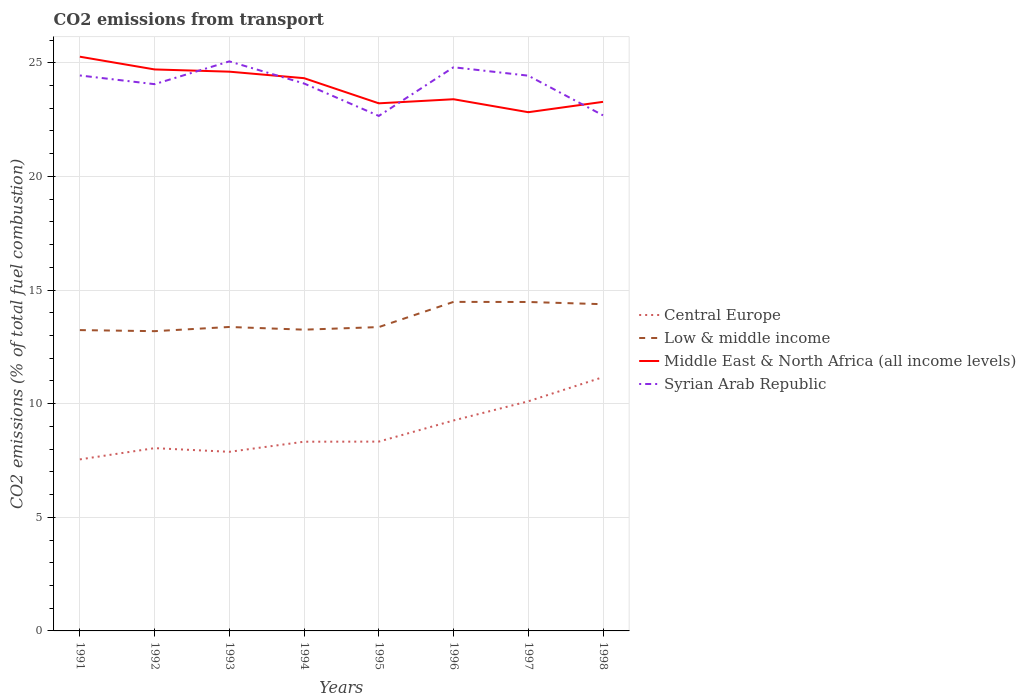How many different coloured lines are there?
Offer a very short reply. 4. Does the line corresponding to Low & middle income intersect with the line corresponding to Middle East & North Africa (all income levels)?
Make the answer very short. No. Across all years, what is the maximum total CO2 emitted in Syrian Arab Republic?
Give a very brief answer. 22.66. What is the total total CO2 emitted in Low & middle income in the graph?
Make the answer very short. -1.19. What is the difference between the highest and the second highest total CO2 emitted in Syrian Arab Republic?
Offer a terse response. 2.4. What is the difference between the highest and the lowest total CO2 emitted in Low & middle income?
Your answer should be very brief. 3. Is the total CO2 emitted in Syrian Arab Republic strictly greater than the total CO2 emitted in Central Europe over the years?
Provide a succinct answer. No. How many lines are there?
Provide a short and direct response. 4. What is the difference between two consecutive major ticks on the Y-axis?
Your answer should be very brief. 5. What is the title of the graph?
Offer a terse response. CO2 emissions from transport. Does "Central African Republic" appear as one of the legend labels in the graph?
Ensure brevity in your answer.  No. What is the label or title of the X-axis?
Make the answer very short. Years. What is the label or title of the Y-axis?
Give a very brief answer. CO2 emissions (% of total fuel combustion). What is the CO2 emissions (% of total fuel combustion) of Central Europe in 1991?
Your answer should be compact. 7.55. What is the CO2 emissions (% of total fuel combustion) in Low & middle income in 1991?
Your answer should be compact. 13.24. What is the CO2 emissions (% of total fuel combustion) of Middle East & North Africa (all income levels) in 1991?
Offer a very short reply. 25.26. What is the CO2 emissions (% of total fuel combustion) in Syrian Arab Republic in 1991?
Provide a succinct answer. 24.44. What is the CO2 emissions (% of total fuel combustion) of Central Europe in 1992?
Provide a succinct answer. 8.04. What is the CO2 emissions (% of total fuel combustion) of Low & middle income in 1992?
Keep it short and to the point. 13.19. What is the CO2 emissions (% of total fuel combustion) of Middle East & North Africa (all income levels) in 1992?
Offer a terse response. 24.7. What is the CO2 emissions (% of total fuel combustion) of Syrian Arab Republic in 1992?
Your answer should be compact. 24.06. What is the CO2 emissions (% of total fuel combustion) in Central Europe in 1993?
Ensure brevity in your answer.  7.88. What is the CO2 emissions (% of total fuel combustion) in Low & middle income in 1993?
Offer a terse response. 13.37. What is the CO2 emissions (% of total fuel combustion) of Middle East & North Africa (all income levels) in 1993?
Offer a very short reply. 24.61. What is the CO2 emissions (% of total fuel combustion) in Syrian Arab Republic in 1993?
Keep it short and to the point. 25.06. What is the CO2 emissions (% of total fuel combustion) of Central Europe in 1994?
Provide a succinct answer. 8.33. What is the CO2 emissions (% of total fuel combustion) in Low & middle income in 1994?
Give a very brief answer. 13.26. What is the CO2 emissions (% of total fuel combustion) of Middle East & North Africa (all income levels) in 1994?
Give a very brief answer. 24.32. What is the CO2 emissions (% of total fuel combustion) in Syrian Arab Republic in 1994?
Your answer should be very brief. 24.09. What is the CO2 emissions (% of total fuel combustion) in Central Europe in 1995?
Provide a short and direct response. 8.33. What is the CO2 emissions (% of total fuel combustion) of Low & middle income in 1995?
Offer a very short reply. 13.37. What is the CO2 emissions (% of total fuel combustion) of Middle East & North Africa (all income levels) in 1995?
Offer a very short reply. 23.21. What is the CO2 emissions (% of total fuel combustion) in Syrian Arab Republic in 1995?
Provide a succinct answer. 22.66. What is the CO2 emissions (% of total fuel combustion) in Central Europe in 1996?
Offer a very short reply. 9.26. What is the CO2 emissions (% of total fuel combustion) of Low & middle income in 1996?
Provide a short and direct response. 14.48. What is the CO2 emissions (% of total fuel combustion) in Middle East & North Africa (all income levels) in 1996?
Offer a terse response. 23.39. What is the CO2 emissions (% of total fuel combustion) of Syrian Arab Republic in 1996?
Provide a short and direct response. 24.8. What is the CO2 emissions (% of total fuel combustion) in Central Europe in 1997?
Keep it short and to the point. 10.1. What is the CO2 emissions (% of total fuel combustion) in Low & middle income in 1997?
Provide a succinct answer. 14.47. What is the CO2 emissions (% of total fuel combustion) of Middle East & North Africa (all income levels) in 1997?
Offer a very short reply. 22.82. What is the CO2 emissions (% of total fuel combustion) in Syrian Arab Republic in 1997?
Offer a very short reply. 24.43. What is the CO2 emissions (% of total fuel combustion) of Central Europe in 1998?
Offer a terse response. 11.17. What is the CO2 emissions (% of total fuel combustion) of Low & middle income in 1998?
Offer a very short reply. 14.38. What is the CO2 emissions (% of total fuel combustion) in Middle East & North Africa (all income levels) in 1998?
Keep it short and to the point. 23.28. What is the CO2 emissions (% of total fuel combustion) of Syrian Arab Republic in 1998?
Offer a very short reply. 22.68. Across all years, what is the maximum CO2 emissions (% of total fuel combustion) in Central Europe?
Ensure brevity in your answer.  11.17. Across all years, what is the maximum CO2 emissions (% of total fuel combustion) in Low & middle income?
Provide a short and direct response. 14.48. Across all years, what is the maximum CO2 emissions (% of total fuel combustion) of Middle East & North Africa (all income levels)?
Your answer should be very brief. 25.26. Across all years, what is the maximum CO2 emissions (% of total fuel combustion) of Syrian Arab Republic?
Keep it short and to the point. 25.06. Across all years, what is the minimum CO2 emissions (% of total fuel combustion) of Central Europe?
Offer a terse response. 7.55. Across all years, what is the minimum CO2 emissions (% of total fuel combustion) in Low & middle income?
Make the answer very short. 13.19. Across all years, what is the minimum CO2 emissions (% of total fuel combustion) of Middle East & North Africa (all income levels)?
Your answer should be very brief. 22.82. Across all years, what is the minimum CO2 emissions (% of total fuel combustion) in Syrian Arab Republic?
Provide a succinct answer. 22.66. What is the total CO2 emissions (% of total fuel combustion) of Central Europe in the graph?
Provide a short and direct response. 70.65. What is the total CO2 emissions (% of total fuel combustion) in Low & middle income in the graph?
Your response must be concise. 109.75. What is the total CO2 emissions (% of total fuel combustion) of Middle East & North Africa (all income levels) in the graph?
Your answer should be compact. 191.61. What is the total CO2 emissions (% of total fuel combustion) in Syrian Arab Republic in the graph?
Your answer should be compact. 192.22. What is the difference between the CO2 emissions (% of total fuel combustion) in Central Europe in 1991 and that in 1992?
Your response must be concise. -0.49. What is the difference between the CO2 emissions (% of total fuel combustion) of Low & middle income in 1991 and that in 1992?
Your answer should be very brief. 0.05. What is the difference between the CO2 emissions (% of total fuel combustion) in Middle East & North Africa (all income levels) in 1991 and that in 1992?
Offer a very short reply. 0.56. What is the difference between the CO2 emissions (% of total fuel combustion) of Syrian Arab Republic in 1991 and that in 1992?
Your answer should be very brief. 0.38. What is the difference between the CO2 emissions (% of total fuel combustion) in Central Europe in 1991 and that in 1993?
Ensure brevity in your answer.  -0.33. What is the difference between the CO2 emissions (% of total fuel combustion) of Low & middle income in 1991 and that in 1993?
Your response must be concise. -0.14. What is the difference between the CO2 emissions (% of total fuel combustion) in Middle East & North Africa (all income levels) in 1991 and that in 1993?
Ensure brevity in your answer.  0.66. What is the difference between the CO2 emissions (% of total fuel combustion) in Syrian Arab Republic in 1991 and that in 1993?
Your answer should be very brief. -0.62. What is the difference between the CO2 emissions (% of total fuel combustion) of Central Europe in 1991 and that in 1994?
Offer a terse response. -0.78. What is the difference between the CO2 emissions (% of total fuel combustion) of Low & middle income in 1991 and that in 1994?
Provide a succinct answer. -0.02. What is the difference between the CO2 emissions (% of total fuel combustion) in Middle East & North Africa (all income levels) in 1991 and that in 1994?
Offer a terse response. 0.94. What is the difference between the CO2 emissions (% of total fuel combustion) in Syrian Arab Republic in 1991 and that in 1994?
Make the answer very short. 0.35. What is the difference between the CO2 emissions (% of total fuel combustion) in Central Europe in 1991 and that in 1995?
Make the answer very short. -0.78. What is the difference between the CO2 emissions (% of total fuel combustion) of Low & middle income in 1991 and that in 1995?
Your answer should be compact. -0.13. What is the difference between the CO2 emissions (% of total fuel combustion) in Middle East & North Africa (all income levels) in 1991 and that in 1995?
Make the answer very short. 2.05. What is the difference between the CO2 emissions (% of total fuel combustion) of Syrian Arab Republic in 1991 and that in 1995?
Offer a terse response. 1.78. What is the difference between the CO2 emissions (% of total fuel combustion) of Central Europe in 1991 and that in 1996?
Provide a short and direct response. -1.71. What is the difference between the CO2 emissions (% of total fuel combustion) of Low & middle income in 1991 and that in 1996?
Your answer should be compact. -1.24. What is the difference between the CO2 emissions (% of total fuel combustion) of Middle East & North Africa (all income levels) in 1991 and that in 1996?
Give a very brief answer. 1.87. What is the difference between the CO2 emissions (% of total fuel combustion) in Syrian Arab Republic in 1991 and that in 1996?
Provide a short and direct response. -0.36. What is the difference between the CO2 emissions (% of total fuel combustion) of Central Europe in 1991 and that in 1997?
Provide a succinct answer. -2.56. What is the difference between the CO2 emissions (% of total fuel combustion) in Low & middle income in 1991 and that in 1997?
Provide a succinct answer. -1.24. What is the difference between the CO2 emissions (% of total fuel combustion) in Middle East & North Africa (all income levels) in 1991 and that in 1997?
Your answer should be compact. 2.44. What is the difference between the CO2 emissions (% of total fuel combustion) of Syrian Arab Republic in 1991 and that in 1997?
Give a very brief answer. 0.01. What is the difference between the CO2 emissions (% of total fuel combustion) in Central Europe in 1991 and that in 1998?
Offer a very short reply. -3.62. What is the difference between the CO2 emissions (% of total fuel combustion) of Low & middle income in 1991 and that in 1998?
Ensure brevity in your answer.  -1.14. What is the difference between the CO2 emissions (% of total fuel combustion) in Middle East & North Africa (all income levels) in 1991 and that in 1998?
Make the answer very short. 1.99. What is the difference between the CO2 emissions (% of total fuel combustion) of Syrian Arab Republic in 1991 and that in 1998?
Give a very brief answer. 1.75. What is the difference between the CO2 emissions (% of total fuel combustion) of Central Europe in 1992 and that in 1993?
Provide a succinct answer. 0.16. What is the difference between the CO2 emissions (% of total fuel combustion) of Low & middle income in 1992 and that in 1993?
Your response must be concise. -0.18. What is the difference between the CO2 emissions (% of total fuel combustion) of Middle East & North Africa (all income levels) in 1992 and that in 1993?
Provide a succinct answer. 0.1. What is the difference between the CO2 emissions (% of total fuel combustion) of Syrian Arab Republic in 1992 and that in 1993?
Your answer should be compact. -1. What is the difference between the CO2 emissions (% of total fuel combustion) of Central Europe in 1992 and that in 1994?
Offer a very short reply. -0.28. What is the difference between the CO2 emissions (% of total fuel combustion) in Low & middle income in 1992 and that in 1994?
Provide a succinct answer. -0.07. What is the difference between the CO2 emissions (% of total fuel combustion) of Middle East & North Africa (all income levels) in 1992 and that in 1994?
Provide a succinct answer. 0.38. What is the difference between the CO2 emissions (% of total fuel combustion) of Syrian Arab Republic in 1992 and that in 1994?
Your response must be concise. -0.03. What is the difference between the CO2 emissions (% of total fuel combustion) in Central Europe in 1992 and that in 1995?
Your response must be concise. -0.29. What is the difference between the CO2 emissions (% of total fuel combustion) of Low & middle income in 1992 and that in 1995?
Your answer should be very brief. -0.18. What is the difference between the CO2 emissions (% of total fuel combustion) in Middle East & North Africa (all income levels) in 1992 and that in 1995?
Give a very brief answer. 1.49. What is the difference between the CO2 emissions (% of total fuel combustion) in Syrian Arab Republic in 1992 and that in 1995?
Your response must be concise. 1.4. What is the difference between the CO2 emissions (% of total fuel combustion) in Central Europe in 1992 and that in 1996?
Ensure brevity in your answer.  -1.22. What is the difference between the CO2 emissions (% of total fuel combustion) in Low & middle income in 1992 and that in 1996?
Your answer should be compact. -1.29. What is the difference between the CO2 emissions (% of total fuel combustion) in Middle East & North Africa (all income levels) in 1992 and that in 1996?
Your answer should be very brief. 1.31. What is the difference between the CO2 emissions (% of total fuel combustion) of Syrian Arab Republic in 1992 and that in 1996?
Your response must be concise. -0.74. What is the difference between the CO2 emissions (% of total fuel combustion) of Central Europe in 1992 and that in 1997?
Your answer should be compact. -2.06. What is the difference between the CO2 emissions (% of total fuel combustion) in Low & middle income in 1992 and that in 1997?
Make the answer very short. -1.28. What is the difference between the CO2 emissions (% of total fuel combustion) of Middle East & North Africa (all income levels) in 1992 and that in 1997?
Your answer should be compact. 1.88. What is the difference between the CO2 emissions (% of total fuel combustion) of Syrian Arab Republic in 1992 and that in 1997?
Your answer should be compact. -0.37. What is the difference between the CO2 emissions (% of total fuel combustion) in Central Europe in 1992 and that in 1998?
Provide a succinct answer. -3.12. What is the difference between the CO2 emissions (% of total fuel combustion) of Low & middle income in 1992 and that in 1998?
Keep it short and to the point. -1.19. What is the difference between the CO2 emissions (% of total fuel combustion) of Middle East & North Africa (all income levels) in 1992 and that in 1998?
Provide a short and direct response. 1.43. What is the difference between the CO2 emissions (% of total fuel combustion) in Syrian Arab Republic in 1992 and that in 1998?
Your answer should be compact. 1.37. What is the difference between the CO2 emissions (% of total fuel combustion) of Central Europe in 1993 and that in 1994?
Offer a very short reply. -0.44. What is the difference between the CO2 emissions (% of total fuel combustion) of Low & middle income in 1993 and that in 1994?
Offer a very short reply. 0.12. What is the difference between the CO2 emissions (% of total fuel combustion) of Middle East & North Africa (all income levels) in 1993 and that in 1994?
Your answer should be very brief. 0.29. What is the difference between the CO2 emissions (% of total fuel combustion) of Syrian Arab Republic in 1993 and that in 1994?
Your answer should be very brief. 0.97. What is the difference between the CO2 emissions (% of total fuel combustion) in Central Europe in 1993 and that in 1995?
Ensure brevity in your answer.  -0.45. What is the difference between the CO2 emissions (% of total fuel combustion) of Low & middle income in 1993 and that in 1995?
Your answer should be compact. 0.01. What is the difference between the CO2 emissions (% of total fuel combustion) in Middle East & North Africa (all income levels) in 1993 and that in 1995?
Provide a succinct answer. 1.39. What is the difference between the CO2 emissions (% of total fuel combustion) in Syrian Arab Republic in 1993 and that in 1995?
Offer a very short reply. 2.4. What is the difference between the CO2 emissions (% of total fuel combustion) of Central Europe in 1993 and that in 1996?
Offer a very short reply. -1.38. What is the difference between the CO2 emissions (% of total fuel combustion) of Low & middle income in 1993 and that in 1996?
Provide a short and direct response. -1.1. What is the difference between the CO2 emissions (% of total fuel combustion) in Middle East & North Africa (all income levels) in 1993 and that in 1996?
Offer a very short reply. 1.21. What is the difference between the CO2 emissions (% of total fuel combustion) in Syrian Arab Republic in 1993 and that in 1996?
Give a very brief answer. 0.26. What is the difference between the CO2 emissions (% of total fuel combustion) in Central Europe in 1993 and that in 1997?
Ensure brevity in your answer.  -2.22. What is the difference between the CO2 emissions (% of total fuel combustion) of Low & middle income in 1993 and that in 1997?
Provide a succinct answer. -1.1. What is the difference between the CO2 emissions (% of total fuel combustion) of Middle East & North Africa (all income levels) in 1993 and that in 1997?
Ensure brevity in your answer.  1.78. What is the difference between the CO2 emissions (% of total fuel combustion) of Syrian Arab Republic in 1993 and that in 1997?
Ensure brevity in your answer.  0.63. What is the difference between the CO2 emissions (% of total fuel combustion) of Central Europe in 1993 and that in 1998?
Provide a succinct answer. -3.29. What is the difference between the CO2 emissions (% of total fuel combustion) in Low & middle income in 1993 and that in 1998?
Your response must be concise. -1. What is the difference between the CO2 emissions (% of total fuel combustion) in Middle East & North Africa (all income levels) in 1993 and that in 1998?
Your response must be concise. 1.33. What is the difference between the CO2 emissions (% of total fuel combustion) of Syrian Arab Republic in 1993 and that in 1998?
Your answer should be compact. 2.37. What is the difference between the CO2 emissions (% of total fuel combustion) of Central Europe in 1994 and that in 1995?
Your response must be concise. -0. What is the difference between the CO2 emissions (% of total fuel combustion) of Low & middle income in 1994 and that in 1995?
Provide a short and direct response. -0.11. What is the difference between the CO2 emissions (% of total fuel combustion) in Middle East & North Africa (all income levels) in 1994 and that in 1995?
Make the answer very short. 1.11. What is the difference between the CO2 emissions (% of total fuel combustion) in Syrian Arab Republic in 1994 and that in 1995?
Keep it short and to the point. 1.43. What is the difference between the CO2 emissions (% of total fuel combustion) in Central Europe in 1994 and that in 1996?
Make the answer very short. -0.93. What is the difference between the CO2 emissions (% of total fuel combustion) of Low & middle income in 1994 and that in 1996?
Offer a terse response. -1.22. What is the difference between the CO2 emissions (% of total fuel combustion) of Middle East & North Africa (all income levels) in 1994 and that in 1996?
Make the answer very short. 0.93. What is the difference between the CO2 emissions (% of total fuel combustion) of Syrian Arab Republic in 1994 and that in 1996?
Make the answer very short. -0.71. What is the difference between the CO2 emissions (% of total fuel combustion) of Central Europe in 1994 and that in 1997?
Your response must be concise. -1.78. What is the difference between the CO2 emissions (% of total fuel combustion) of Low & middle income in 1994 and that in 1997?
Offer a terse response. -1.22. What is the difference between the CO2 emissions (% of total fuel combustion) of Middle East & North Africa (all income levels) in 1994 and that in 1997?
Your response must be concise. 1.5. What is the difference between the CO2 emissions (% of total fuel combustion) in Syrian Arab Republic in 1994 and that in 1997?
Ensure brevity in your answer.  -0.34. What is the difference between the CO2 emissions (% of total fuel combustion) in Central Europe in 1994 and that in 1998?
Provide a short and direct response. -2.84. What is the difference between the CO2 emissions (% of total fuel combustion) of Low & middle income in 1994 and that in 1998?
Give a very brief answer. -1.12. What is the difference between the CO2 emissions (% of total fuel combustion) in Middle East & North Africa (all income levels) in 1994 and that in 1998?
Offer a very short reply. 1.04. What is the difference between the CO2 emissions (% of total fuel combustion) in Syrian Arab Republic in 1994 and that in 1998?
Keep it short and to the point. 1.4. What is the difference between the CO2 emissions (% of total fuel combustion) in Central Europe in 1995 and that in 1996?
Provide a succinct answer. -0.93. What is the difference between the CO2 emissions (% of total fuel combustion) in Low & middle income in 1995 and that in 1996?
Provide a succinct answer. -1.11. What is the difference between the CO2 emissions (% of total fuel combustion) in Middle East & North Africa (all income levels) in 1995 and that in 1996?
Your response must be concise. -0.18. What is the difference between the CO2 emissions (% of total fuel combustion) in Syrian Arab Republic in 1995 and that in 1996?
Your answer should be compact. -2.14. What is the difference between the CO2 emissions (% of total fuel combustion) in Central Europe in 1995 and that in 1997?
Offer a terse response. -1.77. What is the difference between the CO2 emissions (% of total fuel combustion) of Low & middle income in 1995 and that in 1997?
Give a very brief answer. -1.1. What is the difference between the CO2 emissions (% of total fuel combustion) in Middle East & North Africa (all income levels) in 1995 and that in 1997?
Provide a short and direct response. 0.39. What is the difference between the CO2 emissions (% of total fuel combustion) in Syrian Arab Republic in 1995 and that in 1997?
Keep it short and to the point. -1.77. What is the difference between the CO2 emissions (% of total fuel combustion) in Central Europe in 1995 and that in 1998?
Your answer should be very brief. -2.84. What is the difference between the CO2 emissions (% of total fuel combustion) in Low & middle income in 1995 and that in 1998?
Ensure brevity in your answer.  -1.01. What is the difference between the CO2 emissions (% of total fuel combustion) in Middle East & North Africa (all income levels) in 1995 and that in 1998?
Offer a very short reply. -0.06. What is the difference between the CO2 emissions (% of total fuel combustion) in Syrian Arab Republic in 1995 and that in 1998?
Offer a very short reply. -0.03. What is the difference between the CO2 emissions (% of total fuel combustion) of Central Europe in 1996 and that in 1997?
Offer a very short reply. -0.84. What is the difference between the CO2 emissions (% of total fuel combustion) in Low & middle income in 1996 and that in 1997?
Give a very brief answer. 0. What is the difference between the CO2 emissions (% of total fuel combustion) in Middle East & North Africa (all income levels) in 1996 and that in 1997?
Provide a short and direct response. 0.57. What is the difference between the CO2 emissions (% of total fuel combustion) of Syrian Arab Republic in 1996 and that in 1997?
Offer a very short reply. 0.37. What is the difference between the CO2 emissions (% of total fuel combustion) of Central Europe in 1996 and that in 1998?
Your answer should be compact. -1.91. What is the difference between the CO2 emissions (% of total fuel combustion) of Low & middle income in 1996 and that in 1998?
Your response must be concise. 0.1. What is the difference between the CO2 emissions (% of total fuel combustion) of Middle East & North Africa (all income levels) in 1996 and that in 1998?
Give a very brief answer. 0.12. What is the difference between the CO2 emissions (% of total fuel combustion) in Syrian Arab Republic in 1996 and that in 1998?
Offer a terse response. 2.12. What is the difference between the CO2 emissions (% of total fuel combustion) in Central Europe in 1997 and that in 1998?
Provide a succinct answer. -1.06. What is the difference between the CO2 emissions (% of total fuel combustion) of Low & middle income in 1997 and that in 1998?
Make the answer very short. 0.1. What is the difference between the CO2 emissions (% of total fuel combustion) of Middle East & North Africa (all income levels) in 1997 and that in 1998?
Your response must be concise. -0.46. What is the difference between the CO2 emissions (% of total fuel combustion) of Syrian Arab Republic in 1997 and that in 1998?
Make the answer very short. 1.75. What is the difference between the CO2 emissions (% of total fuel combustion) of Central Europe in 1991 and the CO2 emissions (% of total fuel combustion) of Low & middle income in 1992?
Offer a terse response. -5.64. What is the difference between the CO2 emissions (% of total fuel combustion) in Central Europe in 1991 and the CO2 emissions (% of total fuel combustion) in Middle East & North Africa (all income levels) in 1992?
Provide a short and direct response. -17.16. What is the difference between the CO2 emissions (% of total fuel combustion) of Central Europe in 1991 and the CO2 emissions (% of total fuel combustion) of Syrian Arab Republic in 1992?
Provide a short and direct response. -16.51. What is the difference between the CO2 emissions (% of total fuel combustion) of Low & middle income in 1991 and the CO2 emissions (% of total fuel combustion) of Middle East & North Africa (all income levels) in 1992?
Provide a succinct answer. -11.47. What is the difference between the CO2 emissions (% of total fuel combustion) of Low & middle income in 1991 and the CO2 emissions (% of total fuel combustion) of Syrian Arab Republic in 1992?
Provide a short and direct response. -10.82. What is the difference between the CO2 emissions (% of total fuel combustion) of Middle East & North Africa (all income levels) in 1991 and the CO2 emissions (% of total fuel combustion) of Syrian Arab Republic in 1992?
Ensure brevity in your answer.  1.21. What is the difference between the CO2 emissions (% of total fuel combustion) of Central Europe in 1991 and the CO2 emissions (% of total fuel combustion) of Low & middle income in 1993?
Make the answer very short. -5.83. What is the difference between the CO2 emissions (% of total fuel combustion) of Central Europe in 1991 and the CO2 emissions (% of total fuel combustion) of Middle East & North Africa (all income levels) in 1993?
Give a very brief answer. -17.06. What is the difference between the CO2 emissions (% of total fuel combustion) of Central Europe in 1991 and the CO2 emissions (% of total fuel combustion) of Syrian Arab Republic in 1993?
Keep it short and to the point. -17.51. What is the difference between the CO2 emissions (% of total fuel combustion) in Low & middle income in 1991 and the CO2 emissions (% of total fuel combustion) in Middle East & North Africa (all income levels) in 1993?
Offer a very short reply. -11.37. What is the difference between the CO2 emissions (% of total fuel combustion) in Low & middle income in 1991 and the CO2 emissions (% of total fuel combustion) in Syrian Arab Republic in 1993?
Make the answer very short. -11.82. What is the difference between the CO2 emissions (% of total fuel combustion) in Middle East & North Africa (all income levels) in 1991 and the CO2 emissions (% of total fuel combustion) in Syrian Arab Republic in 1993?
Offer a very short reply. 0.21. What is the difference between the CO2 emissions (% of total fuel combustion) of Central Europe in 1991 and the CO2 emissions (% of total fuel combustion) of Low & middle income in 1994?
Your response must be concise. -5.71. What is the difference between the CO2 emissions (% of total fuel combustion) of Central Europe in 1991 and the CO2 emissions (% of total fuel combustion) of Middle East & North Africa (all income levels) in 1994?
Offer a terse response. -16.77. What is the difference between the CO2 emissions (% of total fuel combustion) in Central Europe in 1991 and the CO2 emissions (% of total fuel combustion) in Syrian Arab Republic in 1994?
Offer a terse response. -16.54. What is the difference between the CO2 emissions (% of total fuel combustion) in Low & middle income in 1991 and the CO2 emissions (% of total fuel combustion) in Middle East & North Africa (all income levels) in 1994?
Ensure brevity in your answer.  -11.08. What is the difference between the CO2 emissions (% of total fuel combustion) of Low & middle income in 1991 and the CO2 emissions (% of total fuel combustion) of Syrian Arab Republic in 1994?
Offer a very short reply. -10.85. What is the difference between the CO2 emissions (% of total fuel combustion) of Middle East & North Africa (all income levels) in 1991 and the CO2 emissions (% of total fuel combustion) of Syrian Arab Republic in 1994?
Give a very brief answer. 1.18. What is the difference between the CO2 emissions (% of total fuel combustion) of Central Europe in 1991 and the CO2 emissions (% of total fuel combustion) of Low & middle income in 1995?
Ensure brevity in your answer.  -5.82. What is the difference between the CO2 emissions (% of total fuel combustion) of Central Europe in 1991 and the CO2 emissions (% of total fuel combustion) of Middle East & North Africa (all income levels) in 1995?
Provide a succinct answer. -15.67. What is the difference between the CO2 emissions (% of total fuel combustion) in Central Europe in 1991 and the CO2 emissions (% of total fuel combustion) in Syrian Arab Republic in 1995?
Ensure brevity in your answer.  -15.11. What is the difference between the CO2 emissions (% of total fuel combustion) in Low & middle income in 1991 and the CO2 emissions (% of total fuel combustion) in Middle East & North Africa (all income levels) in 1995?
Offer a terse response. -9.98. What is the difference between the CO2 emissions (% of total fuel combustion) in Low & middle income in 1991 and the CO2 emissions (% of total fuel combustion) in Syrian Arab Republic in 1995?
Make the answer very short. -9.42. What is the difference between the CO2 emissions (% of total fuel combustion) of Middle East & North Africa (all income levels) in 1991 and the CO2 emissions (% of total fuel combustion) of Syrian Arab Republic in 1995?
Offer a terse response. 2.61. What is the difference between the CO2 emissions (% of total fuel combustion) in Central Europe in 1991 and the CO2 emissions (% of total fuel combustion) in Low & middle income in 1996?
Your response must be concise. -6.93. What is the difference between the CO2 emissions (% of total fuel combustion) in Central Europe in 1991 and the CO2 emissions (% of total fuel combustion) in Middle East & North Africa (all income levels) in 1996?
Your answer should be compact. -15.85. What is the difference between the CO2 emissions (% of total fuel combustion) in Central Europe in 1991 and the CO2 emissions (% of total fuel combustion) in Syrian Arab Republic in 1996?
Keep it short and to the point. -17.25. What is the difference between the CO2 emissions (% of total fuel combustion) of Low & middle income in 1991 and the CO2 emissions (% of total fuel combustion) of Middle East & North Africa (all income levels) in 1996?
Make the answer very short. -10.16. What is the difference between the CO2 emissions (% of total fuel combustion) in Low & middle income in 1991 and the CO2 emissions (% of total fuel combustion) in Syrian Arab Republic in 1996?
Ensure brevity in your answer.  -11.56. What is the difference between the CO2 emissions (% of total fuel combustion) in Middle East & North Africa (all income levels) in 1991 and the CO2 emissions (% of total fuel combustion) in Syrian Arab Republic in 1996?
Provide a short and direct response. 0.46. What is the difference between the CO2 emissions (% of total fuel combustion) of Central Europe in 1991 and the CO2 emissions (% of total fuel combustion) of Low & middle income in 1997?
Offer a terse response. -6.93. What is the difference between the CO2 emissions (% of total fuel combustion) of Central Europe in 1991 and the CO2 emissions (% of total fuel combustion) of Middle East & North Africa (all income levels) in 1997?
Give a very brief answer. -15.28. What is the difference between the CO2 emissions (% of total fuel combustion) in Central Europe in 1991 and the CO2 emissions (% of total fuel combustion) in Syrian Arab Republic in 1997?
Provide a succinct answer. -16.88. What is the difference between the CO2 emissions (% of total fuel combustion) of Low & middle income in 1991 and the CO2 emissions (% of total fuel combustion) of Middle East & North Africa (all income levels) in 1997?
Provide a short and direct response. -9.59. What is the difference between the CO2 emissions (% of total fuel combustion) of Low & middle income in 1991 and the CO2 emissions (% of total fuel combustion) of Syrian Arab Republic in 1997?
Your response must be concise. -11.2. What is the difference between the CO2 emissions (% of total fuel combustion) of Middle East & North Africa (all income levels) in 1991 and the CO2 emissions (% of total fuel combustion) of Syrian Arab Republic in 1997?
Your response must be concise. 0.83. What is the difference between the CO2 emissions (% of total fuel combustion) of Central Europe in 1991 and the CO2 emissions (% of total fuel combustion) of Low & middle income in 1998?
Keep it short and to the point. -6.83. What is the difference between the CO2 emissions (% of total fuel combustion) of Central Europe in 1991 and the CO2 emissions (% of total fuel combustion) of Middle East & North Africa (all income levels) in 1998?
Make the answer very short. -15.73. What is the difference between the CO2 emissions (% of total fuel combustion) of Central Europe in 1991 and the CO2 emissions (% of total fuel combustion) of Syrian Arab Republic in 1998?
Give a very brief answer. -15.14. What is the difference between the CO2 emissions (% of total fuel combustion) in Low & middle income in 1991 and the CO2 emissions (% of total fuel combustion) in Middle East & North Africa (all income levels) in 1998?
Provide a short and direct response. -10.04. What is the difference between the CO2 emissions (% of total fuel combustion) of Low & middle income in 1991 and the CO2 emissions (% of total fuel combustion) of Syrian Arab Republic in 1998?
Make the answer very short. -9.45. What is the difference between the CO2 emissions (% of total fuel combustion) in Middle East & North Africa (all income levels) in 1991 and the CO2 emissions (% of total fuel combustion) in Syrian Arab Republic in 1998?
Make the answer very short. 2.58. What is the difference between the CO2 emissions (% of total fuel combustion) in Central Europe in 1992 and the CO2 emissions (% of total fuel combustion) in Low & middle income in 1993?
Your response must be concise. -5.33. What is the difference between the CO2 emissions (% of total fuel combustion) in Central Europe in 1992 and the CO2 emissions (% of total fuel combustion) in Middle East & North Africa (all income levels) in 1993?
Your response must be concise. -16.57. What is the difference between the CO2 emissions (% of total fuel combustion) in Central Europe in 1992 and the CO2 emissions (% of total fuel combustion) in Syrian Arab Republic in 1993?
Provide a short and direct response. -17.02. What is the difference between the CO2 emissions (% of total fuel combustion) in Low & middle income in 1992 and the CO2 emissions (% of total fuel combustion) in Middle East & North Africa (all income levels) in 1993?
Provide a succinct answer. -11.42. What is the difference between the CO2 emissions (% of total fuel combustion) in Low & middle income in 1992 and the CO2 emissions (% of total fuel combustion) in Syrian Arab Republic in 1993?
Your answer should be very brief. -11.87. What is the difference between the CO2 emissions (% of total fuel combustion) of Middle East & North Africa (all income levels) in 1992 and the CO2 emissions (% of total fuel combustion) of Syrian Arab Republic in 1993?
Make the answer very short. -0.35. What is the difference between the CO2 emissions (% of total fuel combustion) in Central Europe in 1992 and the CO2 emissions (% of total fuel combustion) in Low & middle income in 1994?
Your response must be concise. -5.21. What is the difference between the CO2 emissions (% of total fuel combustion) in Central Europe in 1992 and the CO2 emissions (% of total fuel combustion) in Middle East & North Africa (all income levels) in 1994?
Your answer should be compact. -16.28. What is the difference between the CO2 emissions (% of total fuel combustion) of Central Europe in 1992 and the CO2 emissions (% of total fuel combustion) of Syrian Arab Republic in 1994?
Make the answer very short. -16.04. What is the difference between the CO2 emissions (% of total fuel combustion) in Low & middle income in 1992 and the CO2 emissions (% of total fuel combustion) in Middle East & North Africa (all income levels) in 1994?
Provide a succinct answer. -11.13. What is the difference between the CO2 emissions (% of total fuel combustion) in Low & middle income in 1992 and the CO2 emissions (% of total fuel combustion) in Syrian Arab Republic in 1994?
Offer a very short reply. -10.9. What is the difference between the CO2 emissions (% of total fuel combustion) in Middle East & North Africa (all income levels) in 1992 and the CO2 emissions (% of total fuel combustion) in Syrian Arab Republic in 1994?
Give a very brief answer. 0.62. What is the difference between the CO2 emissions (% of total fuel combustion) in Central Europe in 1992 and the CO2 emissions (% of total fuel combustion) in Low & middle income in 1995?
Offer a terse response. -5.33. What is the difference between the CO2 emissions (% of total fuel combustion) in Central Europe in 1992 and the CO2 emissions (% of total fuel combustion) in Middle East & North Africa (all income levels) in 1995?
Ensure brevity in your answer.  -15.17. What is the difference between the CO2 emissions (% of total fuel combustion) of Central Europe in 1992 and the CO2 emissions (% of total fuel combustion) of Syrian Arab Republic in 1995?
Offer a terse response. -14.62. What is the difference between the CO2 emissions (% of total fuel combustion) in Low & middle income in 1992 and the CO2 emissions (% of total fuel combustion) in Middle East & North Africa (all income levels) in 1995?
Your answer should be compact. -10.03. What is the difference between the CO2 emissions (% of total fuel combustion) in Low & middle income in 1992 and the CO2 emissions (% of total fuel combustion) in Syrian Arab Republic in 1995?
Provide a succinct answer. -9.47. What is the difference between the CO2 emissions (% of total fuel combustion) of Middle East & North Africa (all income levels) in 1992 and the CO2 emissions (% of total fuel combustion) of Syrian Arab Republic in 1995?
Provide a succinct answer. 2.05. What is the difference between the CO2 emissions (% of total fuel combustion) in Central Europe in 1992 and the CO2 emissions (% of total fuel combustion) in Low & middle income in 1996?
Your answer should be compact. -6.44. What is the difference between the CO2 emissions (% of total fuel combustion) in Central Europe in 1992 and the CO2 emissions (% of total fuel combustion) in Middle East & North Africa (all income levels) in 1996?
Give a very brief answer. -15.35. What is the difference between the CO2 emissions (% of total fuel combustion) of Central Europe in 1992 and the CO2 emissions (% of total fuel combustion) of Syrian Arab Republic in 1996?
Provide a short and direct response. -16.76. What is the difference between the CO2 emissions (% of total fuel combustion) in Low & middle income in 1992 and the CO2 emissions (% of total fuel combustion) in Middle East & North Africa (all income levels) in 1996?
Keep it short and to the point. -10.21. What is the difference between the CO2 emissions (% of total fuel combustion) in Low & middle income in 1992 and the CO2 emissions (% of total fuel combustion) in Syrian Arab Republic in 1996?
Your answer should be very brief. -11.61. What is the difference between the CO2 emissions (% of total fuel combustion) in Middle East & North Africa (all income levels) in 1992 and the CO2 emissions (% of total fuel combustion) in Syrian Arab Republic in 1996?
Make the answer very short. -0.1. What is the difference between the CO2 emissions (% of total fuel combustion) of Central Europe in 1992 and the CO2 emissions (% of total fuel combustion) of Low & middle income in 1997?
Keep it short and to the point. -6.43. What is the difference between the CO2 emissions (% of total fuel combustion) of Central Europe in 1992 and the CO2 emissions (% of total fuel combustion) of Middle East & North Africa (all income levels) in 1997?
Your response must be concise. -14.78. What is the difference between the CO2 emissions (% of total fuel combustion) of Central Europe in 1992 and the CO2 emissions (% of total fuel combustion) of Syrian Arab Republic in 1997?
Your answer should be very brief. -16.39. What is the difference between the CO2 emissions (% of total fuel combustion) in Low & middle income in 1992 and the CO2 emissions (% of total fuel combustion) in Middle East & North Africa (all income levels) in 1997?
Offer a very short reply. -9.63. What is the difference between the CO2 emissions (% of total fuel combustion) of Low & middle income in 1992 and the CO2 emissions (% of total fuel combustion) of Syrian Arab Republic in 1997?
Provide a short and direct response. -11.24. What is the difference between the CO2 emissions (% of total fuel combustion) of Middle East & North Africa (all income levels) in 1992 and the CO2 emissions (% of total fuel combustion) of Syrian Arab Republic in 1997?
Offer a terse response. 0.27. What is the difference between the CO2 emissions (% of total fuel combustion) in Central Europe in 1992 and the CO2 emissions (% of total fuel combustion) in Low & middle income in 1998?
Offer a very short reply. -6.33. What is the difference between the CO2 emissions (% of total fuel combustion) in Central Europe in 1992 and the CO2 emissions (% of total fuel combustion) in Middle East & North Africa (all income levels) in 1998?
Your answer should be very brief. -15.24. What is the difference between the CO2 emissions (% of total fuel combustion) of Central Europe in 1992 and the CO2 emissions (% of total fuel combustion) of Syrian Arab Republic in 1998?
Ensure brevity in your answer.  -14.64. What is the difference between the CO2 emissions (% of total fuel combustion) in Low & middle income in 1992 and the CO2 emissions (% of total fuel combustion) in Middle East & North Africa (all income levels) in 1998?
Make the answer very short. -10.09. What is the difference between the CO2 emissions (% of total fuel combustion) of Low & middle income in 1992 and the CO2 emissions (% of total fuel combustion) of Syrian Arab Republic in 1998?
Your response must be concise. -9.5. What is the difference between the CO2 emissions (% of total fuel combustion) in Middle East & North Africa (all income levels) in 1992 and the CO2 emissions (% of total fuel combustion) in Syrian Arab Republic in 1998?
Provide a short and direct response. 2.02. What is the difference between the CO2 emissions (% of total fuel combustion) in Central Europe in 1993 and the CO2 emissions (% of total fuel combustion) in Low & middle income in 1994?
Your answer should be compact. -5.37. What is the difference between the CO2 emissions (% of total fuel combustion) of Central Europe in 1993 and the CO2 emissions (% of total fuel combustion) of Middle East & North Africa (all income levels) in 1994?
Provide a short and direct response. -16.44. What is the difference between the CO2 emissions (% of total fuel combustion) in Central Europe in 1993 and the CO2 emissions (% of total fuel combustion) in Syrian Arab Republic in 1994?
Provide a short and direct response. -16.21. What is the difference between the CO2 emissions (% of total fuel combustion) in Low & middle income in 1993 and the CO2 emissions (% of total fuel combustion) in Middle East & North Africa (all income levels) in 1994?
Offer a terse response. -10.95. What is the difference between the CO2 emissions (% of total fuel combustion) of Low & middle income in 1993 and the CO2 emissions (% of total fuel combustion) of Syrian Arab Republic in 1994?
Your answer should be very brief. -10.71. What is the difference between the CO2 emissions (% of total fuel combustion) in Middle East & North Africa (all income levels) in 1993 and the CO2 emissions (% of total fuel combustion) in Syrian Arab Republic in 1994?
Offer a terse response. 0.52. What is the difference between the CO2 emissions (% of total fuel combustion) in Central Europe in 1993 and the CO2 emissions (% of total fuel combustion) in Low & middle income in 1995?
Your response must be concise. -5.49. What is the difference between the CO2 emissions (% of total fuel combustion) in Central Europe in 1993 and the CO2 emissions (% of total fuel combustion) in Middle East & North Africa (all income levels) in 1995?
Provide a succinct answer. -15.33. What is the difference between the CO2 emissions (% of total fuel combustion) of Central Europe in 1993 and the CO2 emissions (% of total fuel combustion) of Syrian Arab Republic in 1995?
Keep it short and to the point. -14.78. What is the difference between the CO2 emissions (% of total fuel combustion) in Low & middle income in 1993 and the CO2 emissions (% of total fuel combustion) in Middle East & North Africa (all income levels) in 1995?
Provide a succinct answer. -9.84. What is the difference between the CO2 emissions (% of total fuel combustion) of Low & middle income in 1993 and the CO2 emissions (% of total fuel combustion) of Syrian Arab Republic in 1995?
Provide a succinct answer. -9.29. What is the difference between the CO2 emissions (% of total fuel combustion) in Middle East & North Africa (all income levels) in 1993 and the CO2 emissions (% of total fuel combustion) in Syrian Arab Republic in 1995?
Keep it short and to the point. 1.95. What is the difference between the CO2 emissions (% of total fuel combustion) in Central Europe in 1993 and the CO2 emissions (% of total fuel combustion) in Low & middle income in 1996?
Provide a short and direct response. -6.6. What is the difference between the CO2 emissions (% of total fuel combustion) in Central Europe in 1993 and the CO2 emissions (% of total fuel combustion) in Middle East & North Africa (all income levels) in 1996?
Provide a short and direct response. -15.51. What is the difference between the CO2 emissions (% of total fuel combustion) of Central Europe in 1993 and the CO2 emissions (% of total fuel combustion) of Syrian Arab Republic in 1996?
Give a very brief answer. -16.92. What is the difference between the CO2 emissions (% of total fuel combustion) in Low & middle income in 1993 and the CO2 emissions (% of total fuel combustion) in Middle East & North Africa (all income levels) in 1996?
Your answer should be compact. -10.02. What is the difference between the CO2 emissions (% of total fuel combustion) of Low & middle income in 1993 and the CO2 emissions (% of total fuel combustion) of Syrian Arab Republic in 1996?
Offer a very short reply. -11.43. What is the difference between the CO2 emissions (% of total fuel combustion) in Middle East & North Africa (all income levels) in 1993 and the CO2 emissions (% of total fuel combustion) in Syrian Arab Republic in 1996?
Keep it short and to the point. -0.19. What is the difference between the CO2 emissions (% of total fuel combustion) in Central Europe in 1993 and the CO2 emissions (% of total fuel combustion) in Low & middle income in 1997?
Provide a succinct answer. -6.59. What is the difference between the CO2 emissions (% of total fuel combustion) of Central Europe in 1993 and the CO2 emissions (% of total fuel combustion) of Middle East & North Africa (all income levels) in 1997?
Provide a short and direct response. -14.94. What is the difference between the CO2 emissions (% of total fuel combustion) in Central Europe in 1993 and the CO2 emissions (% of total fuel combustion) in Syrian Arab Republic in 1997?
Offer a terse response. -16.55. What is the difference between the CO2 emissions (% of total fuel combustion) of Low & middle income in 1993 and the CO2 emissions (% of total fuel combustion) of Middle East & North Africa (all income levels) in 1997?
Keep it short and to the point. -9.45. What is the difference between the CO2 emissions (% of total fuel combustion) in Low & middle income in 1993 and the CO2 emissions (% of total fuel combustion) in Syrian Arab Republic in 1997?
Your answer should be very brief. -11.06. What is the difference between the CO2 emissions (% of total fuel combustion) of Middle East & North Africa (all income levels) in 1993 and the CO2 emissions (% of total fuel combustion) of Syrian Arab Republic in 1997?
Ensure brevity in your answer.  0.18. What is the difference between the CO2 emissions (% of total fuel combustion) of Central Europe in 1993 and the CO2 emissions (% of total fuel combustion) of Low & middle income in 1998?
Ensure brevity in your answer.  -6.5. What is the difference between the CO2 emissions (% of total fuel combustion) of Central Europe in 1993 and the CO2 emissions (% of total fuel combustion) of Middle East & North Africa (all income levels) in 1998?
Offer a very short reply. -15.4. What is the difference between the CO2 emissions (% of total fuel combustion) in Central Europe in 1993 and the CO2 emissions (% of total fuel combustion) in Syrian Arab Republic in 1998?
Ensure brevity in your answer.  -14.8. What is the difference between the CO2 emissions (% of total fuel combustion) in Low & middle income in 1993 and the CO2 emissions (% of total fuel combustion) in Middle East & North Africa (all income levels) in 1998?
Your response must be concise. -9.91. What is the difference between the CO2 emissions (% of total fuel combustion) in Low & middle income in 1993 and the CO2 emissions (% of total fuel combustion) in Syrian Arab Republic in 1998?
Offer a terse response. -9.31. What is the difference between the CO2 emissions (% of total fuel combustion) in Middle East & North Africa (all income levels) in 1993 and the CO2 emissions (% of total fuel combustion) in Syrian Arab Republic in 1998?
Your response must be concise. 1.92. What is the difference between the CO2 emissions (% of total fuel combustion) in Central Europe in 1994 and the CO2 emissions (% of total fuel combustion) in Low & middle income in 1995?
Give a very brief answer. -5.04. What is the difference between the CO2 emissions (% of total fuel combustion) of Central Europe in 1994 and the CO2 emissions (% of total fuel combustion) of Middle East & North Africa (all income levels) in 1995?
Offer a very short reply. -14.89. What is the difference between the CO2 emissions (% of total fuel combustion) of Central Europe in 1994 and the CO2 emissions (% of total fuel combustion) of Syrian Arab Republic in 1995?
Offer a terse response. -14.33. What is the difference between the CO2 emissions (% of total fuel combustion) of Low & middle income in 1994 and the CO2 emissions (% of total fuel combustion) of Middle East & North Africa (all income levels) in 1995?
Give a very brief answer. -9.96. What is the difference between the CO2 emissions (% of total fuel combustion) in Low & middle income in 1994 and the CO2 emissions (% of total fuel combustion) in Syrian Arab Republic in 1995?
Offer a very short reply. -9.4. What is the difference between the CO2 emissions (% of total fuel combustion) of Middle East & North Africa (all income levels) in 1994 and the CO2 emissions (% of total fuel combustion) of Syrian Arab Republic in 1995?
Give a very brief answer. 1.66. What is the difference between the CO2 emissions (% of total fuel combustion) of Central Europe in 1994 and the CO2 emissions (% of total fuel combustion) of Low & middle income in 1996?
Ensure brevity in your answer.  -6.15. What is the difference between the CO2 emissions (% of total fuel combustion) in Central Europe in 1994 and the CO2 emissions (% of total fuel combustion) in Middle East & North Africa (all income levels) in 1996?
Keep it short and to the point. -15.07. What is the difference between the CO2 emissions (% of total fuel combustion) of Central Europe in 1994 and the CO2 emissions (% of total fuel combustion) of Syrian Arab Republic in 1996?
Keep it short and to the point. -16.48. What is the difference between the CO2 emissions (% of total fuel combustion) of Low & middle income in 1994 and the CO2 emissions (% of total fuel combustion) of Middle East & North Africa (all income levels) in 1996?
Your answer should be compact. -10.14. What is the difference between the CO2 emissions (% of total fuel combustion) of Low & middle income in 1994 and the CO2 emissions (% of total fuel combustion) of Syrian Arab Republic in 1996?
Your response must be concise. -11.55. What is the difference between the CO2 emissions (% of total fuel combustion) of Middle East & North Africa (all income levels) in 1994 and the CO2 emissions (% of total fuel combustion) of Syrian Arab Republic in 1996?
Offer a terse response. -0.48. What is the difference between the CO2 emissions (% of total fuel combustion) in Central Europe in 1994 and the CO2 emissions (% of total fuel combustion) in Low & middle income in 1997?
Ensure brevity in your answer.  -6.15. What is the difference between the CO2 emissions (% of total fuel combustion) in Central Europe in 1994 and the CO2 emissions (% of total fuel combustion) in Middle East & North Africa (all income levels) in 1997?
Provide a succinct answer. -14.5. What is the difference between the CO2 emissions (% of total fuel combustion) in Central Europe in 1994 and the CO2 emissions (% of total fuel combustion) in Syrian Arab Republic in 1997?
Make the answer very short. -16.11. What is the difference between the CO2 emissions (% of total fuel combustion) in Low & middle income in 1994 and the CO2 emissions (% of total fuel combustion) in Middle East & North Africa (all income levels) in 1997?
Your response must be concise. -9.57. What is the difference between the CO2 emissions (% of total fuel combustion) of Low & middle income in 1994 and the CO2 emissions (% of total fuel combustion) of Syrian Arab Republic in 1997?
Ensure brevity in your answer.  -11.18. What is the difference between the CO2 emissions (% of total fuel combustion) in Middle East & North Africa (all income levels) in 1994 and the CO2 emissions (% of total fuel combustion) in Syrian Arab Republic in 1997?
Ensure brevity in your answer.  -0.11. What is the difference between the CO2 emissions (% of total fuel combustion) of Central Europe in 1994 and the CO2 emissions (% of total fuel combustion) of Low & middle income in 1998?
Give a very brief answer. -6.05. What is the difference between the CO2 emissions (% of total fuel combustion) in Central Europe in 1994 and the CO2 emissions (% of total fuel combustion) in Middle East & North Africa (all income levels) in 1998?
Make the answer very short. -14.95. What is the difference between the CO2 emissions (% of total fuel combustion) in Central Europe in 1994 and the CO2 emissions (% of total fuel combustion) in Syrian Arab Republic in 1998?
Keep it short and to the point. -14.36. What is the difference between the CO2 emissions (% of total fuel combustion) of Low & middle income in 1994 and the CO2 emissions (% of total fuel combustion) of Middle East & North Africa (all income levels) in 1998?
Offer a very short reply. -10.02. What is the difference between the CO2 emissions (% of total fuel combustion) of Low & middle income in 1994 and the CO2 emissions (% of total fuel combustion) of Syrian Arab Republic in 1998?
Your answer should be very brief. -9.43. What is the difference between the CO2 emissions (% of total fuel combustion) in Middle East & North Africa (all income levels) in 1994 and the CO2 emissions (% of total fuel combustion) in Syrian Arab Republic in 1998?
Provide a short and direct response. 1.64. What is the difference between the CO2 emissions (% of total fuel combustion) in Central Europe in 1995 and the CO2 emissions (% of total fuel combustion) in Low & middle income in 1996?
Give a very brief answer. -6.15. What is the difference between the CO2 emissions (% of total fuel combustion) in Central Europe in 1995 and the CO2 emissions (% of total fuel combustion) in Middle East & North Africa (all income levels) in 1996?
Ensure brevity in your answer.  -15.06. What is the difference between the CO2 emissions (% of total fuel combustion) of Central Europe in 1995 and the CO2 emissions (% of total fuel combustion) of Syrian Arab Republic in 1996?
Provide a short and direct response. -16.47. What is the difference between the CO2 emissions (% of total fuel combustion) in Low & middle income in 1995 and the CO2 emissions (% of total fuel combustion) in Middle East & North Africa (all income levels) in 1996?
Make the answer very short. -10.03. What is the difference between the CO2 emissions (% of total fuel combustion) of Low & middle income in 1995 and the CO2 emissions (% of total fuel combustion) of Syrian Arab Republic in 1996?
Provide a succinct answer. -11.43. What is the difference between the CO2 emissions (% of total fuel combustion) in Middle East & North Africa (all income levels) in 1995 and the CO2 emissions (% of total fuel combustion) in Syrian Arab Republic in 1996?
Give a very brief answer. -1.59. What is the difference between the CO2 emissions (% of total fuel combustion) in Central Europe in 1995 and the CO2 emissions (% of total fuel combustion) in Low & middle income in 1997?
Keep it short and to the point. -6.14. What is the difference between the CO2 emissions (% of total fuel combustion) of Central Europe in 1995 and the CO2 emissions (% of total fuel combustion) of Middle East & North Africa (all income levels) in 1997?
Offer a very short reply. -14.49. What is the difference between the CO2 emissions (% of total fuel combustion) in Central Europe in 1995 and the CO2 emissions (% of total fuel combustion) in Syrian Arab Republic in 1997?
Provide a short and direct response. -16.1. What is the difference between the CO2 emissions (% of total fuel combustion) in Low & middle income in 1995 and the CO2 emissions (% of total fuel combustion) in Middle East & North Africa (all income levels) in 1997?
Your response must be concise. -9.45. What is the difference between the CO2 emissions (% of total fuel combustion) in Low & middle income in 1995 and the CO2 emissions (% of total fuel combustion) in Syrian Arab Republic in 1997?
Give a very brief answer. -11.06. What is the difference between the CO2 emissions (% of total fuel combustion) of Middle East & North Africa (all income levels) in 1995 and the CO2 emissions (% of total fuel combustion) of Syrian Arab Republic in 1997?
Offer a very short reply. -1.22. What is the difference between the CO2 emissions (% of total fuel combustion) in Central Europe in 1995 and the CO2 emissions (% of total fuel combustion) in Low & middle income in 1998?
Provide a succinct answer. -6.05. What is the difference between the CO2 emissions (% of total fuel combustion) of Central Europe in 1995 and the CO2 emissions (% of total fuel combustion) of Middle East & North Africa (all income levels) in 1998?
Give a very brief answer. -14.95. What is the difference between the CO2 emissions (% of total fuel combustion) of Central Europe in 1995 and the CO2 emissions (% of total fuel combustion) of Syrian Arab Republic in 1998?
Provide a short and direct response. -14.36. What is the difference between the CO2 emissions (% of total fuel combustion) in Low & middle income in 1995 and the CO2 emissions (% of total fuel combustion) in Middle East & North Africa (all income levels) in 1998?
Your answer should be very brief. -9.91. What is the difference between the CO2 emissions (% of total fuel combustion) of Low & middle income in 1995 and the CO2 emissions (% of total fuel combustion) of Syrian Arab Republic in 1998?
Keep it short and to the point. -9.32. What is the difference between the CO2 emissions (% of total fuel combustion) in Middle East & North Africa (all income levels) in 1995 and the CO2 emissions (% of total fuel combustion) in Syrian Arab Republic in 1998?
Keep it short and to the point. 0.53. What is the difference between the CO2 emissions (% of total fuel combustion) in Central Europe in 1996 and the CO2 emissions (% of total fuel combustion) in Low & middle income in 1997?
Provide a short and direct response. -5.21. What is the difference between the CO2 emissions (% of total fuel combustion) of Central Europe in 1996 and the CO2 emissions (% of total fuel combustion) of Middle East & North Africa (all income levels) in 1997?
Make the answer very short. -13.56. What is the difference between the CO2 emissions (% of total fuel combustion) of Central Europe in 1996 and the CO2 emissions (% of total fuel combustion) of Syrian Arab Republic in 1997?
Offer a terse response. -15.17. What is the difference between the CO2 emissions (% of total fuel combustion) of Low & middle income in 1996 and the CO2 emissions (% of total fuel combustion) of Middle East & North Africa (all income levels) in 1997?
Make the answer very short. -8.35. What is the difference between the CO2 emissions (% of total fuel combustion) in Low & middle income in 1996 and the CO2 emissions (% of total fuel combustion) in Syrian Arab Republic in 1997?
Give a very brief answer. -9.95. What is the difference between the CO2 emissions (% of total fuel combustion) in Middle East & North Africa (all income levels) in 1996 and the CO2 emissions (% of total fuel combustion) in Syrian Arab Republic in 1997?
Provide a succinct answer. -1.04. What is the difference between the CO2 emissions (% of total fuel combustion) in Central Europe in 1996 and the CO2 emissions (% of total fuel combustion) in Low & middle income in 1998?
Provide a succinct answer. -5.12. What is the difference between the CO2 emissions (% of total fuel combustion) in Central Europe in 1996 and the CO2 emissions (% of total fuel combustion) in Middle East & North Africa (all income levels) in 1998?
Offer a terse response. -14.02. What is the difference between the CO2 emissions (% of total fuel combustion) of Central Europe in 1996 and the CO2 emissions (% of total fuel combustion) of Syrian Arab Republic in 1998?
Keep it short and to the point. -13.42. What is the difference between the CO2 emissions (% of total fuel combustion) in Low & middle income in 1996 and the CO2 emissions (% of total fuel combustion) in Middle East & North Africa (all income levels) in 1998?
Your answer should be compact. -8.8. What is the difference between the CO2 emissions (% of total fuel combustion) of Low & middle income in 1996 and the CO2 emissions (% of total fuel combustion) of Syrian Arab Republic in 1998?
Your answer should be compact. -8.21. What is the difference between the CO2 emissions (% of total fuel combustion) of Middle East & North Africa (all income levels) in 1996 and the CO2 emissions (% of total fuel combustion) of Syrian Arab Republic in 1998?
Your answer should be very brief. 0.71. What is the difference between the CO2 emissions (% of total fuel combustion) in Central Europe in 1997 and the CO2 emissions (% of total fuel combustion) in Low & middle income in 1998?
Provide a short and direct response. -4.27. What is the difference between the CO2 emissions (% of total fuel combustion) of Central Europe in 1997 and the CO2 emissions (% of total fuel combustion) of Middle East & North Africa (all income levels) in 1998?
Keep it short and to the point. -13.18. What is the difference between the CO2 emissions (% of total fuel combustion) in Central Europe in 1997 and the CO2 emissions (% of total fuel combustion) in Syrian Arab Republic in 1998?
Keep it short and to the point. -12.58. What is the difference between the CO2 emissions (% of total fuel combustion) in Low & middle income in 1997 and the CO2 emissions (% of total fuel combustion) in Middle East & North Africa (all income levels) in 1998?
Provide a succinct answer. -8.81. What is the difference between the CO2 emissions (% of total fuel combustion) of Low & middle income in 1997 and the CO2 emissions (% of total fuel combustion) of Syrian Arab Republic in 1998?
Your answer should be compact. -8.21. What is the difference between the CO2 emissions (% of total fuel combustion) in Middle East & North Africa (all income levels) in 1997 and the CO2 emissions (% of total fuel combustion) in Syrian Arab Republic in 1998?
Provide a short and direct response. 0.14. What is the average CO2 emissions (% of total fuel combustion) in Central Europe per year?
Provide a short and direct response. 8.83. What is the average CO2 emissions (% of total fuel combustion) in Low & middle income per year?
Your answer should be very brief. 13.72. What is the average CO2 emissions (% of total fuel combustion) of Middle East & North Africa (all income levels) per year?
Provide a succinct answer. 23.95. What is the average CO2 emissions (% of total fuel combustion) in Syrian Arab Republic per year?
Give a very brief answer. 24.03. In the year 1991, what is the difference between the CO2 emissions (% of total fuel combustion) of Central Europe and CO2 emissions (% of total fuel combustion) of Low & middle income?
Offer a terse response. -5.69. In the year 1991, what is the difference between the CO2 emissions (% of total fuel combustion) of Central Europe and CO2 emissions (% of total fuel combustion) of Middle East & North Africa (all income levels)?
Make the answer very short. -17.72. In the year 1991, what is the difference between the CO2 emissions (% of total fuel combustion) of Central Europe and CO2 emissions (% of total fuel combustion) of Syrian Arab Republic?
Keep it short and to the point. -16.89. In the year 1991, what is the difference between the CO2 emissions (% of total fuel combustion) in Low & middle income and CO2 emissions (% of total fuel combustion) in Middle East & North Africa (all income levels)?
Your response must be concise. -12.03. In the year 1991, what is the difference between the CO2 emissions (% of total fuel combustion) in Low & middle income and CO2 emissions (% of total fuel combustion) in Syrian Arab Republic?
Your answer should be very brief. -11.2. In the year 1991, what is the difference between the CO2 emissions (% of total fuel combustion) in Middle East & North Africa (all income levels) and CO2 emissions (% of total fuel combustion) in Syrian Arab Republic?
Offer a terse response. 0.83. In the year 1992, what is the difference between the CO2 emissions (% of total fuel combustion) in Central Europe and CO2 emissions (% of total fuel combustion) in Low & middle income?
Offer a very short reply. -5.15. In the year 1992, what is the difference between the CO2 emissions (% of total fuel combustion) of Central Europe and CO2 emissions (% of total fuel combustion) of Middle East & North Africa (all income levels)?
Give a very brief answer. -16.66. In the year 1992, what is the difference between the CO2 emissions (% of total fuel combustion) in Central Europe and CO2 emissions (% of total fuel combustion) in Syrian Arab Republic?
Offer a terse response. -16.02. In the year 1992, what is the difference between the CO2 emissions (% of total fuel combustion) of Low & middle income and CO2 emissions (% of total fuel combustion) of Middle East & North Africa (all income levels)?
Ensure brevity in your answer.  -11.52. In the year 1992, what is the difference between the CO2 emissions (% of total fuel combustion) of Low & middle income and CO2 emissions (% of total fuel combustion) of Syrian Arab Republic?
Your response must be concise. -10.87. In the year 1992, what is the difference between the CO2 emissions (% of total fuel combustion) of Middle East & North Africa (all income levels) and CO2 emissions (% of total fuel combustion) of Syrian Arab Republic?
Give a very brief answer. 0.65. In the year 1993, what is the difference between the CO2 emissions (% of total fuel combustion) in Central Europe and CO2 emissions (% of total fuel combustion) in Low & middle income?
Your answer should be very brief. -5.49. In the year 1993, what is the difference between the CO2 emissions (% of total fuel combustion) of Central Europe and CO2 emissions (% of total fuel combustion) of Middle East & North Africa (all income levels)?
Offer a terse response. -16.73. In the year 1993, what is the difference between the CO2 emissions (% of total fuel combustion) in Central Europe and CO2 emissions (% of total fuel combustion) in Syrian Arab Republic?
Keep it short and to the point. -17.18. In the year 1993, what is the difference between the CO2 emissions (% of total fuel combustion) of Low & middle income and CO2 emissions (% of total fuel combustion) of Middle East & North Africa (all income levels)?
Offer a terse response. -11.23. In the year 1993, what is the difference between the CO2 emissions (% of total fuel combustion) of Low & middle income and CO2 emissions (% of total fuel combustion) of Syrian Arab Republic?
Offer a terse response. -11.69. In the year 1993, what is the difference between the CO2 emissions (% of total fuel combustion) in Middle East & North Africa (all income levels) and CO2 emissions (% of total fuel combustion) in Syrian Arab Republic?
Ensure brevity in your answer.  -0.45. In the year 1994, what is the difference between the CO2 emissions (% of total fuel combustion) in Central Europe and CO2 emissions (% of total fuel combustion) in Low & middle income?
Offer a very short reply. -4.93. In the year 1994, what is the difference between the CO2 emissions (% of total fuel combustion) in Central Europe and CO2 emissions (% of total fuel combustion) in Middle East & North Africa (all income levels)?
Provide a short and direct response. -16. In the year 1994, what is the difference between the CO2 emissions (% of total fuel combustion) in Central Europe and CO2 emissions (% of total fuel combustion) in Syrian Arab Republic?
Your answer should be compact. -15.76. In the year 1994, what is the difference between the CO2 emissions (% of total fuel combustion) in Low & middle income and CO2 emissions (% of total fuel combustion) in Middle East & North Africa (all income levels)?
Give a very brief answer. -11.07. In the year 1994, what is the difference between the CO2 emissions (% of total fuel combustion) in Low & middle income and CO2 emissions (% of total fuel combustion) in Syrian Arab Republic?
Your answer should be very brief. -10.83. In the year 1994, what is the difference between the CO2 emissions (% of total fuel combustion) in Middle East & North Africa (all income levels) and CO2 emissions (% of total fuel combustion) in Syrian Arab Republic?
Your answer should be very brief. 0.23. In the year 1995, what is the difference between the CO2 emissions (% of total fuel combustion) of Central Europe and CO2 emissions (% of total fuel combustion) of Low & middle income?
Give a very brief answer. -5.04. In the year 1995, what is the difference between the CO2 emissions (% of total fuel combustion) of Central Europe and CO2 emissions (% of total fuel combustion) of Middle East & North Africa (all income levels)?
Give a very brief answer. -14.88. In the year 1995, what is the difference between the CO2 emissions (% of total fuel combustion) in Central Europe and CO2 emissions (% of total fuel combustion) in Syrian Arab Republic?
Provide a short and direct response. -14.33. In the year 1995, what is the difference between the CO2 emissions (% of total fuel combustion) in Low & middle income and CO2 emissions (% of total fuel combustion) in Middle East & North Africa (all income levels)?
Your answer should be very brief. -9.85. In the year 1995, what is the difference between the CO2 emissions (% of total fuel combustion) in Low & middle income and CO2 emissions (% of total fuel combustion) in Syrian Arab Republic?
Provide a succinct answer. -9.29. In the year 1995, what is the difference between the CO2 emissions (% of total fuel combustion) in Middle East & North Africa (all income levels) and CO2 emissions (% of total fuel combustion) in Syrian Arab Republic?
Offer a very short reply. 0.55. In the year 1996, what is the difference between the CO2 emissions (% of total fuel combustion) in Central Europe and CO2 emissions (% of total fuel combustion) in Low & middle income?
Your response must be concise. -5.22. In the year 1996, what is the difference between the CO2 emissions (% of total fuel combustion) in Central Europe and CO2 emissions (% of total fuel combustion) in Middle East & North Africa (all income levels)?
Your answer should be compact. -14.13. In the year 1996, what is the difference between the CO2 emissions (% of total fuel combustion) in Central Europe and CO2 emissions (% of total fuel combustion) in Syrian Arab Republic?
Offer a very short reply. -15.54. In the year 1996, what is the difference between the CO2 emissions (% of total fuel combustion) of Low & middle income and CO2 emissions (% of total fuel combustion) of Middle East & North Africa (all income levels)?
Provide a short and direct response. -8.92. In the year 1996, what is the difference between the CO2 emissions (% of total fuel combustion) in Low & middle income and CO2 emissions (% of total fuel combustion) in Syrian Arab Republic?
Provide a short and direct response. -10.32. In the year 1996, what is the difference between the CO2 emissions (% of total fuel combustion) of Middle East & North Africa (all income levels) and CO2 emissions (% of total fuel combustion) of Syrian Arab Republic?
Ensure brevity in your answer.  -1.41. In the year 1997, what is the difference between the CO2 emissions (% of total fuel combustion) in Central Europe and CO2 emissions (% of total fuel combustion) in Low & middle income?
Your response must be concise. -4.37. In the year 1997, what is the difference between the CO2 emissions (% of total fuel combustion) in Central Europe and CO2 emissions (% of total fuel combustion) in Middle East & North Africa (all income levels)?
Your answer should be compact. -12.72. In the year 1997, what is the difference between the CO2 emissions (% of total fuel combustion) in Central Europe and CO2 emissions (% of total fuel combustion) in Syrian Arab Republic?
Ensure brevity in your answer.  -14.33. In the year 1997, what is the difference between the CO2 emissions (% of total fuel combustion) in Low & middle income and CO2 emissions (% of total fuel combustion) in Middle East & North Africa (all income levels)?
Give a very brief answer. -8.35. In the year 1997, what is the difference between the CO2 emissions (% of total fuel combustion) in Low & middle income and CO2 emissions (% of total fuel combustion) in Syrian Arab Republic?
Offer a very short reply. -9.96. In the year 1997, what is the difference between the CO2 emissions (% of total fuel combustion) of Middle East & North Africa (all income levels) and CO2 emissions (% of total fuel combustion) of Syrian Arab Republic?
Give a very brief answer. -1.61. In the year 1998, what is the difference between the CO2 emissions (% of total fuel combustion) in Central Europe and CO2 emissions (% of total fuel combustion) in Low & middle income?
Keep it short and to the point. -3.21. In the year 1998, what is the difference between the CO2 emissions (% of total fuel combustion) of Central Europe and CO2 emissions (% of total fuel combustion) of Middle East & North Africa (all income levels)?
Provide a short and direct response. -12.11. In the year 1998, what is the difference between the CO2 emissions (% of total fuel combustion) in Central Europe and CO2 emissions (% of total fuel combustion) in Syrian Arab Republic?
Your answer should be compact. -11.52. In the year 1998, what is the difference between the CO2 emissions (% of total fuel combustion) in Low & middle income and CO2 emissions (% of total fuel combustion) in Middle East & North Africa (all income levels)?
Your response must be concise. -8.9. In the year 1998, what is the difference between the CO2 emissions (% of total fuel combustion) in Low & middle income and CO2 emissions (% of total fuel combustion) in Syrian Arab Republic?
Give a very brief answer. -8.31. In the year 1998, what is the difference between the CO2 emissions (% of total fuel combustion) in Middle East & North Africa (all income levels) and CO2 emissions (% of total fuel combustion) in Syrian Arab Republic?
Offer a terse response. 0.59. What is the ratio of the CO2 emissions (% of total fuel combustion) of Central Europe in 1991 to that in 1992?
Give a very brief answer. 0.94. What is the ratio of the CO2 emissions (% of total fuel combustion) of Middle East & North Africa (all income levels) in 1991 to that in 1992?
Your answer should be very brief. 1.02. What is the ratio of the CO2 emissions (% of total fuel combustion) in Syrian Arab Republic in 1991 to that in 1992?
Make the answer very short. 1.02. What is the ratio of the CO2 emissions (% of total fuel combustion) in Central Europe in 1991 to that in 1993?
Your answer should be very brief. 0.96. What is the ratio of the CO2 emissions (% of total fuel combustion) of Middle East & North Africa (all income levels) in 1991 to that in 1993?
Your answer should be very brief. 1.03. What is the ratio of the CO2 emissions (% of total fuel combustion) in Syrian Arab Republic in 1991 to that in 1993?
Your answer should be compact. 0.98. What is the ratio of the CO2 emissions (% of total fuel combustion) in Central Europe in 1991 to that in 1994?
Offer a very short reply. 0.91. What is the ratio of the CO2 emissions (% of total fuel combustion) in Middle East & North Africa (all income levels) in 1991 to that in 1994?
Ensure brevity in your answer.  1.04. What is the ratio of the CO2 emissions (% of total fuel combustion) in Syrian Arab Republic in 1991 to that in 1994?
Provide a short and direct response. 1.01. What is the ratio of the CO2 emissions (% of total fuel combustion) of Central Europe in 1991 to that in 1995?
Make the answer very short. 0.91. What is the ratio of the CO2 emissions (% of total fuel combustion) in Low & middle income in 1991 to that in 1995?
Your response must be concise. 0.99. What is the ratio of the CO2 emissions (% of total fuel combustion) in Middle East & North Africa (all income levels) in 1991 to that in 1995?
Your answer should be compact. 1.09. What is the ratio of the CO2 emissions (% of total fuel combustion) in Syrian Arab Republic in 1991 to that in 1995?
Offer a terse response. 1.08. What is the ratio of the CO2 emissions (% of total fuel combustion) of Central Europe in 1991 to that in 1996?
Make the answer very short. 0.81. What is the ratio of the CO2 emissions (% of total fuel combustion) in Low & middle income in 1991 to that in 1996?
Your answer should be compact. 0.91. What is the ratio of the CO2 emissions (% of total fuel combustion) in Middle East & North Africa (all income levels) in 1991 to that in 1996?
Make the answer very short. 1.08. What is the ratio of the CO2 emissions (% of total fuel combustion) in Syrian Arab Republic in 1991 to that in 1996?
Your answer should be compact. 0.99. What is the ratio of the CO2 emissions (% of total fuel combustion) in Central Europe in 1991 to that in 1997?
Provide a short and direct response. 0.75. What is the ratio of the CO2 emissions (% of total fuel combustion) of Low & middle income in 1991 to that in 1997?
Provide a succinct answer. 0.91. What is the ratio of the CO2 emissions (% of total fuel combustion) of Middle East & North Africa (all income levels) in 1991 to that in 1997?
Your response must be concise. 1.11. What is the ratio of the CO2 emissions (% of total fuel combustion) of Central Europe in 1991 to that in 1998?
Make the answer very short. 0.68. What is the ratio of the CO2 emissions (% of total fuel combustion) of Low & middle income in 1991 to that in 1998?
Offer a terse response. 0.92. What is the ratio of the CO2 emissions (% of total fuel combustion) of Middle East & North Africa (all income levels) in 1991 to that in 1998?
Your answer should be very brief. 1.09. What is the ratio of the CO2 emissions (% of total fuel combustion) in Syrian Arab Republic in 1991 to that in 1998?
Ensure brevity in your answer.  1.08. What is the ratio of the CO2 emissions (% of total fuel combustion) in Central Europe in 1992 to that in 1993?
Keep it short and to the point. 1.02. What is the ratio of the CO2 emissions (% of total fuel combustion) of Low & middle income in 1992 to that in 1993?
Offer a very short reply. 0.99. What is the ratio of the CO2 emissions (% of total fuel combustion) in Syrian Arab Republic in 1992 to that in 1993?
Provide a short and direct response. 0.96. What is the ratio of the CO2 emissions (% of total fuel combustion) of Central Europe in 1992 to that in 1994?
Provide a succinct answer. 0.97. What is the ratio of the CO2 emissions (% of total fuel combustion) in Low & middle income in 1992 to that in 1994?
Keep it short and to the point. 0.99. What is the ratio of the CO2 emissions (% of total fuel combustion) of Middle East & North Africa (all income levels) in 1992 to that in 1994?
Give a very brief answer. 1.02. What is the ratio of the CO2 emissions (% of total fuel combustion) of Central Europe in 1992 to that in 1995?
Offer a terse response. 0.97. What is the ratio of the CO2 emissions (% of total fuel combustion) of Low & middle income in 1992 to that in 1995?
Make the answer very short. 0.99. What is the ratio of the CO2 emissions (% of total fuel combustion) of Middle East & North Africa (all income levels) in 1992 to that in 1995?
Provide a short and direct response. 1.06. What is the ratio of the CO2 emissions (% of total fuel combustion) of Syrian Arab Republic in 1992 to that in 1995?
Make the answer very short. 1.06. What is the ratio of the CO2 emissions (% of total fuel combustion) of Central Europe in 1992 to that in 1996?
Your answer should be very brief. 0.87. What is the ratio of the CO2 emissions (% of total fuel combustion) of Low & middle income in 1992 to that in 1996?
Offer a very short reply. 0.91. What is the ratio of the CO2 emissions (% of total fuel combustion) in Middle East & North Africa (all income levels) in 1992 to that in 1996?
Offer a terse response. 1.06. What is the ratio of the CO2 emissions (% of total fuel combustion) of Central Europe in 1992 to that in 1997?
Your answer should be compact. 0.8. What is the ratio of the CO2 emissions (% of total fuel combustion) in Low & middle income in 1992 to that in 1997?
Ensure brevity in your answer.  0.91. What is the ratio of the CO2 emissions (% of total fuel combustion) in Middle East & North Africa (all income levels) in 1992 to that in 1997?
Keep it short and to the point. 1.08. What is the ratio of the CO2 emissions (% of total fuel combustion) in Syrian Arab Republic in 1992 to that in 1997?
Make the answer very short. 0.98. What is the ratio of the CO2 emissions (% of total fuel combustion) of Central Europe in 1992 to that in 1998?
Your response must be concise. 0.72. What is the ratio of the CO2 emissions (% of total fuel combustion) of Low & middle income in 1992 to that in 1998?
Give a very brief answer. 0.92. What is the ratio of the CO2 emissions (% of total fuel combustion) in Middle East & North Africa (all income levels) in 1992 to that in 1998?
Offer a terse response. 1.06. What is the ratio of the CO2 emissions (% of total fuel combustion) in Syrian Arab Republic in 1992 to that in 1998?
Ensure brevity in your answer.  1.06. What is the ratio of the CO2 emissions (% of total fuel combustion) in Central Europe in 1993 to that in 1994?
Provide a short and direct response. 0.95. What is the ratio of the CO2 emissions (% of total fuel combustion) of Low & middle income in 1993 to that in 1994?
Your answer should be very brief. 1.01. What is the ratio of the CO2 emissions (% of total fuel combustion) of Middle East & North Africa (all income levels) in 1993 to that in 1994?
Give a very brief answer. 1.01. What is the ratio of the CO2 emissions (% of total fuel combustion) in Syrian Arab Republic in 1993 to that in 1994?
Offer a very short reply. 1.04. What is the ratio of the CO2 emissions (% of total fuel combustion) in Central Europe in 1993 to that in 1995?
Give a very brief answer. 0.95. What is the ratio of the CO2 emissions (% of total fuel combustion) of Middle East & North Africa (all income levels) in 1993 to that in 1995?
Offer a very short reply. 1.06. What is the ratio of the CO2 emissions (% of total fuel combustion) of Syrian Arab Republic in 1993 to that in 1995?
Provide a succinct answer. 1.11. What is the ratio of the CO2 emissions (% of total fuel combustion) in Central Europe in 1993 to that in 1996?
Ensure brevity in your answer.  0.85. What is the ratio of the CO2 emissions (% of total fuel combustion) of Low & middle income in 1993 to that in 1996?
Give a very brief answer. 0.92. What is the ratio of the CO2 emissions (% of total fuel combustion) in Middle East & North Africa (all income levels) in 1993 to that in 1996?
Offer a very short reply. 1.05. What is the ratio of the CO2 emissions (% of total fuel combustion) in Syrian Arab Republic in 1993 to that in 1996?
Your response must be concise. 1.01. What is the ratio of the CO2 emissions (% of total fuel combustion) in Central Europe in 1993 to that in 1997?
Provide a short and direct response. 0.78. What is the ratio of the CO2 emissions (% of total fuel combustion) of Low & middle income in 1993 to that in 1997?
Make the answer very short. 0.92. What is the ratio of the CO2 emissions (% of total fuel combustion) of Middle East & North Africa (all income levels) in 1993 to that in 1997?
Offer a very short reply. 1.08. What is the ratio of the CO2 emissions (% of total fuel combustion) in Syrian Arab Republic in 1993 to that in 1997?
Your answer should be very brief. 1.03. What is the ratio of the CO2 emissions (% of total fuel combustion) of Central Europe in 1993 to that in 1998?
Ensure brevity in your answer.  0.71. What is the ratio of the CO2 emissions (% of total fuel combustion) in Low & middle income in 1993 to that in 1998?
Provide a short and direct response. 0.93. What is the ratio of the CO2 emissions (% of total fuel combustion) in Middle East & North Africa (all income levels) in 1993 to that in 1998?
Your answer should be very brief. 1.06. What is the ratio of the CO2 emissions (% of total fuel combustion) of Syrian Arab Republic in 1993 to that in 1998?
Provide a succinct answer. 1.1. What is the ratio of the CO2 emissions (% of total fuel combustion) of Middle East & North Africa (all income levels) in 1994 to that in 1995?
Your response must be concise. 1.05. What is the ratio of the CO2 emissions (% of total fuel combustion) of Syrian Arab Republic in 1994 to that in 1995?
Ensure brevity in your answer.  1.06. What is the ratio of the CO2 emissions (% of total fuel combustion) in Central Europe in 1994 to that in 1996?
Provide a short and direct response. 0.9. What is the ratio of the CO2 emissions (% of total fuel combustion) of Low & middle income in 1994 to that in 1996?
Provide a short and direct response. 0.92. What is the ratio of the CO2 emissions (% of total fuel combustion) of Middle East & North Africa (all income levels) in 1994 to that in 1996?
Provide a short and direct response. 1.04. What is the ratio of the CO2 emissions (% of total fuel combustion) of Syrian Arab Republic in 1994 to that in 1996?
Provide a succinct answer. 0.97. What is the ratio of the CO2 emissions (% of total fuel combustion) in Central Europe in 1994 to that in 1997?
Make the answer very short. 0.82. What is the ratio of the CO2 emissions (% of total fuel combustion) of Low & middle income in 1994 to that in 1997?
Offer a terse response. 0.92. What is the ratio of the CO2 emissions (% of total fuel combustion) in Middle East & North Africa (all income levels) in 1994 to that in 1997?
Your answer should be very brief. 1.07. What is the ratio of the CO2 emissions (% of total fuel combustion) in Syrian Arab Republic in 1994 to that in 1997?
Give a very brief answer. 0.99. What is the ratio of the CO2 emissions (% of total fuel combustion) of Central Europe in 1994 to that in 1998?
Your response must be concise. 0.75. What is the ratio of the CO2 emissions (% of total fuel combustion) in Low & middle income in 1994 to that in 1998?
Your answer should be very brief. 0.92. What is the ratio of the CO2 emissions (% of total fuel combustion) of Middle East & North Africa (all income levels) in 1994 to that in 1998?
Keep it short and to the point. 1.04. What is the ratio of the CO2 emissions (% of total fuel combustion) of Syrian Arab Republic in 1994 to that in 1998?
Offer a terse response. 1.06. What is the ratio of the CO2 emissions (% of total fuel combustion) in Central Europe in 1995 to that in 1996?
Your answer should be very brief. 0.9. What is the ratio of the CO2 emissions (% of total fuel combustion) in Low & middle income in 1995 to that in 1996?
Ensure brevity in your answer.  0.92. What is the ratio of the CO2 emissions (% of total fuel combustion) of Syrian Arab Republic in 1995 to that in 1996?
Provide a succinct answer. 0.91. What is the ratio of the CO2 emissions (% of total fuel combustion) in Central Europe in 1995 to that in 1997?
Your answer should be compact. 0.82. What is the ratio of the CO2 emissions (% of total fuel combustion) in Low & middle income in 1995 to that in 1997?
Provide a short and direct response. 0.92. What is the ratio of the CO2 emissions (% of total fuel combustion) of Middle East & North Africa (all income levels) in 1995 to that in 1997?
Keep it short and to the point. 1.02. What is the ratio of the CO2 emissions (% of total fuel combustion) in Syrian Arab Republic in 1995 to that in 1997?
Your answer should be compact. 0.93. What is the ratio of the CO2 emissions (% of total fuel combustion) of Central Europe in 1995 to that in 1998?
Provide a short and direct response. 0.75. What is the ratio of the CO2 emissions (% of total fuel combustion) of Low & middle income in 1995 to that in 1998?
Give a very brief answer. 0.93. What is the ratio of the CO2 emissions (% of total fuel combustion) in Middle East & North Africa (all income levels) in 1995 to that in 1998?
Provide a succinct answer. 1. What is the ratio of the CO2 emissions (% of total fuel combustion) of Syrian Arab Republic in 1995 to that in 1998?
Ensure brevity in your answer.  1. What is the ratio of the CO2 emissions (% of total fuel combustion) in Central Europe in 1996 to that in 1997?
Your response must be concise. 0.92. What is the ratio of the CO2 emissions (% of total fuel combustion) in Middle East & North Africa (all income levels) in 1996 to that in 1997?
Provide a succinct answer. 1.02. What is the ratio of the CO2 emissions (% of total fuel combustion) of Syrian Arab Republic in 1996 to that in 1997?
Ensure brevity in your answer.  1.02. What is the ratio of the CO2 emissions (% of total fuel combustion) in Central Europe in 1996 to that in 1998?
Offer a terse response. 0.83. What is the ratio of the CO2 emissions (% of total fuel combustion) of Low & middle income in 1996 to that in 1998?
Provide a succinct answer. 1.01. What is the ratio of the CO2 emissions (% of total fuel combustion) of Syrian Arab Republic in 1996 to that in 1998?
Ensure brevity in your answer.  1.09. What is the ratio of the CO2 emissions (% of total fuel combustion) of Central Europe in 1997 to that in 1998?
Make the answer very short. 0.9. What is the ratio of the CO2 emissions (% of total fuel combustion) in Middle East & North Africa (all income levels) in 1997 to that in 1998?
Offer a very short reply. 0.98. What is the ratio of the CO2 emissions (% of total fuel combustion) in Syrian Arab Republic in 1997 to that in 1998?
Your answer should be very brief. 1.08. What is the difference between the highest and the second highest CO2 emissions (% of total fuel combustion) of Central Europe?
Provide a short and direct response. 1.06. What is the difference between the highest and the second highest CO2 emissions (% of total fuel combustion) in Low & middle income?
Your answer should be compact. 0. What is the difference between the highest and the second highest CO2 emissions (% of total fuel combustion) in Middle East & North Africa (all income levels)?
Give a very brief answer. 0.56. What is the difference between the highest and the second highest CO2 emissions (% of total fuel combustion) in Syrian Arab Republic?
Provide a succinct answer. 0.26. What is the difference between the highest and the lowest CO2 emissions (% of total fuel combustion) in Central Europe?
Ensure brevity in your answer.  3.62. What is the difference between the highest and the lowest CO2 emissions (% of total fuel combustion) in Low & middle income?
Your answer should be compact. 1.29. What is the difference between the highest and the lowest CO2 emissions (% of total fuel combustion) in Middle East & North Africa (all income levels)?
Ensure brevity in your answer.  2.44. What is the difference between the highest and the lowest CO2 emissions (% of total fuel combustion) in Syrian Arab Republic?
Ensure brevity in your answer.  2.4. 